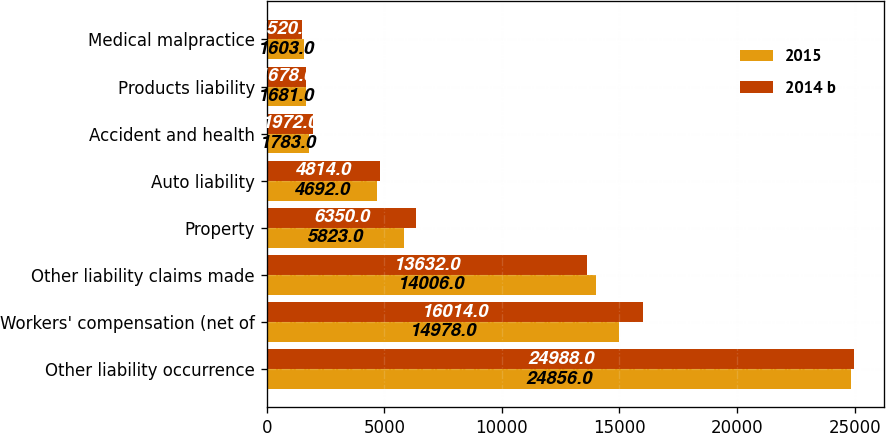Convert chart. <chart><loc_0><loc_0><loc_500><loc_500><stacked_bar_chart><ecel><fcel>Other liability occurrence<fcel>Workers' compensation (net of<fcel>Other liability claims made<fcel>Property<fcel>Auto liability<fcel>Accident and health<fcel>Products liability<fcel>Medical malpractice<nl><fcel>2015<fcel>24856<fcel>14978<fcel>14006<fcel>5823<fcel>4692<fcel>1783<fcel>1681<fcel>1603<nl><fcel>2014 b<fcel>24988<fcel>16014<fcel>13632<fcel>6350<fcel>4814<fcel>1972<fcel>1678<fcel>1520<nl></chart> 